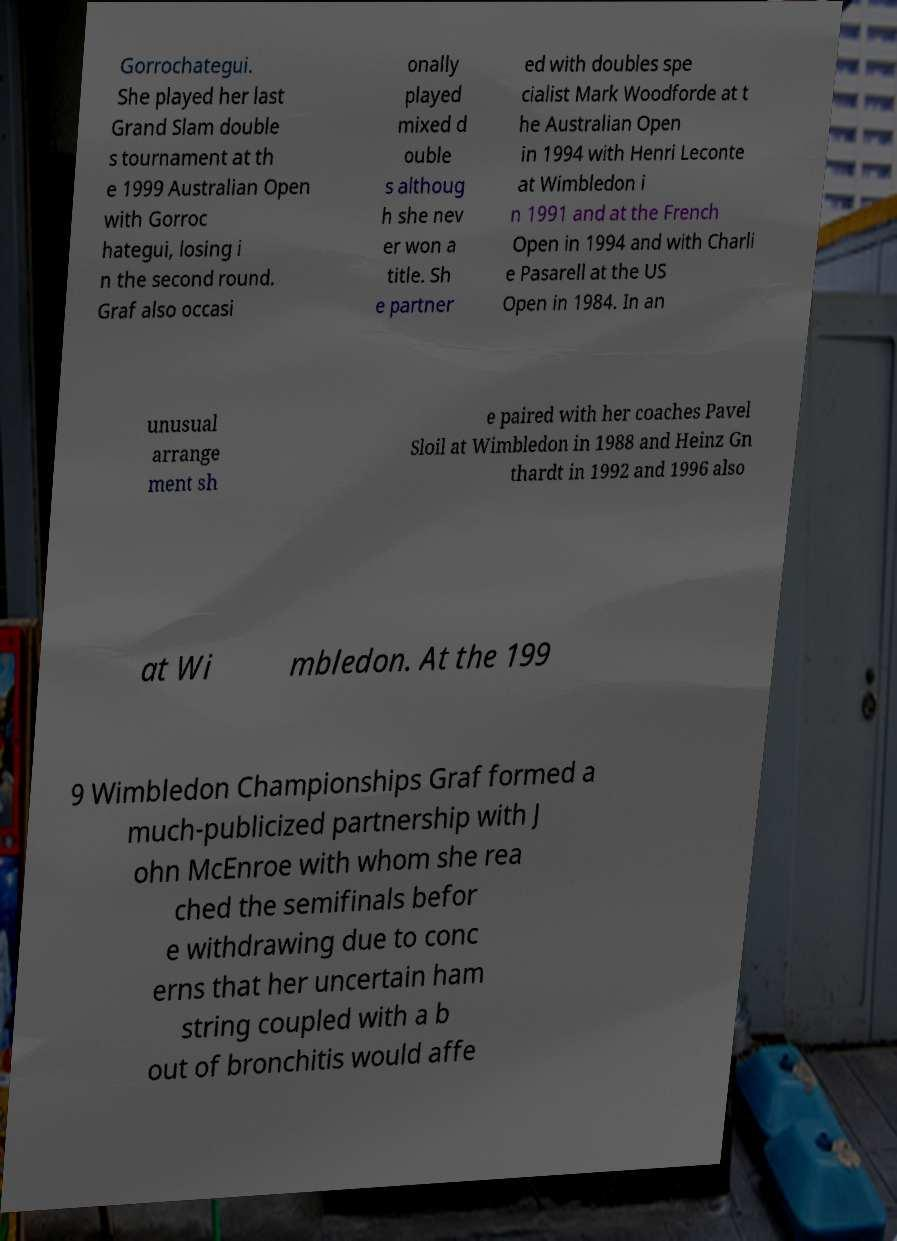Could you assist in decoding the text presented in this image and type it out clearly? Gorrochategui. She played her last Grand Slam double s tournament at th e 1999 Australian Open with Gorroc hategui, losing i n the second round. Graf also occasi onally played mixed d ouble s althoug h she nev er won a title. Sh e partner ed with doubles spe cialist Mark Woodforde at t he Australian Open in 1994 with Henri Leconte at Wimbledon i n 1991 and at the French Open in 1994 and with Charli e Pasarell at the US Open in 1984. In an unusual arrange ment sh e paired with her coaches Pavel Sloil at Wimbledon in 1988 and Heinz Gn thardt in 1992 and 1996 also at Wi mbledon. At the 199 9 Wimbledon Championships Graf formed a much-publicized partnership with J ohn McEnroe with whom she rea ched the semifinals befor e withdrawing due to conc erns that her uncertain ham string coupled with a b out of bronchitis would affe 